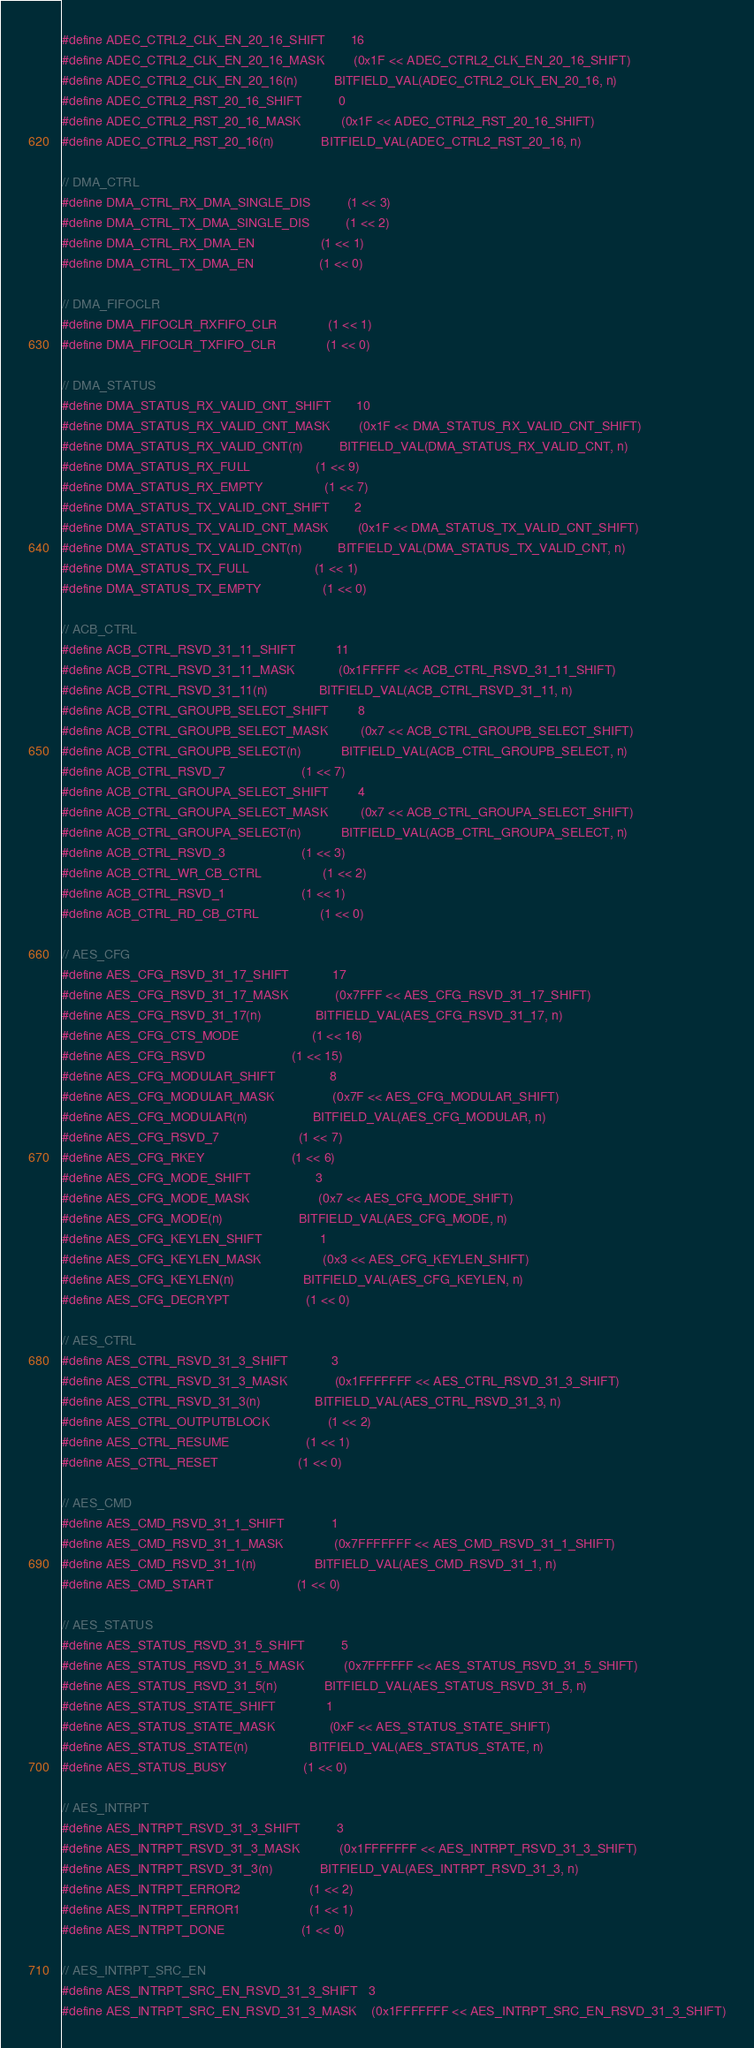Convert code to text. <code><loc_0><loc_0><loc_500><loc_500><_C_>#define ADEC_CTRL2_CLK_EN_20_16_SHIFT       16
#define ADEC_CTRL2_CLK_EN_20_16_MASK        (0x1F << ADEC_CTRL2_CLK_EN_20_16_SHIFT)
#define ADEC_CTRL2_CLK_EN_20_16(n)          BITFIELD_VAL(ADEC_CTRL2_CLK_EN_20_16, n)
#define ADEC_CTRL2_RST_20_16_SHIFT          0
#define ADEC_CTRL2_RST_20_16_MASK           (0x1F << ADEC_CTRL2_RST_20_16_SHIFT)
#define ADEC_CTRL2_RST_20_16(n)             BITFIELD_VAL(ADEC_CTRL2_RST_20_16, n)

// DMA_CTRL
#define DMA_CTRL_RX_DMA_SINGLE_DIS          (1 << 3)
#define DMA_CTRL_TX_DMA_SINGLE_DIS          (1 << 2)
#define DMA_CTRL_RX_DMA_EN                  (1 << 1)
#define DMA_CTRL_TX_DMA_EN                  (1 << 0)

// DMA_FIFOCLR
#define DMA_FIFOCLR_RXFIFO_CLR              (1 << 1)
#define DMA_FIFOCLR_TXFIFO_CLR              (1 << 0)

// DMA_STATUS
#define DMA_STATUS_RX_VALID_CNT_SHIFT       10
#define DMA_STATUS_RX_VALID_CNT_MASK        (0x1F << DMA_STATUS_RX_VALID_CNT_SHIFT)
#define DMA_STATUS_RX_VALID_CNT(n)          BITFIELD_VAL(DMA_STATUS_RX_VALID_CNT, n)
#define DMA_STATUS_RX_FULL                  (1 << 9)
#define DMA_STATUS_RX_EMPTY                 (1 << 7)
#define DMA_STATUS_TX_VALID_CNT_SHIFT       2
#define DMA_STATUS_TX_VALID_CNT_MASK        (0x1F << DMA_STATUS_TX_VALID_CNT_SHIFT)
#define DMA_STATUS_TX_VALID_CNT(n)          BITFIELD_VAL(DMA_STATUS_TX_VALID_CNT, n)
#define DMA_STATUS_TX_FULL                  (1 << 1)
#define DMA_STATUS_TX_EMPTY                 (1 << 0)

// ACB_CTRL
#define ACB_CTRL_RSVD_31_11_SHIFT           11
#define ACB_CTRL_RSVD_31_11_MASK            (0x1FFFFF << ACB_CTRL_RSVD_31_11_SHIFT)
#define ACB_CTRL_RSVD_31_11(n)              BITFIELD_VAL(ACB_CTRL_RSVD_31_11, n)
#define ACB_CTRL_GROUPB_SELECT_SHIFT        8
#define ACB_CTRL_GROUPB_SELECT_MASK         (0x7 << ACB_CTRL_GROUPB_SELECT_SHIFT)
#define ACB_CTRL_GROUPB_SELECT(n)           BITFIELD_VAL(ACB_CTRL_GROUPB_SELECT, n)
#define ACB_CTRL_RSVD_7                     (1 << 7)
#define ACB_CTRL_GROUPA_SELECT_SHIFT        4
#define ACB_CTRL_GROUPA_SELECT_MASK         (0x7 << ACB_CTRL_GROUPA_SELECT_SHIFT)
#define ACB_CTRL_GROUPA_SELECT(n)           BITFIELD_VAL(ACB_CTRL_GROUPA_SELECT, n)
#define ACB_CTRL_RSVD_3                     (1 << 3)
#define ACB_CTRL_WR_CB_CTRL                 (1 << 2)
#define ACB_CTRL_RSVD_1                     (1 << 1)
#define ACB_CTRL_RD_CB_CTRL                 (1 << 0)

// AES_CFG
#define AES_CFG_RSVD_31_17_SHIFT            17
#define AES_CFG_RSVD_31_17_MASK             (0x7FFF << AES_CFG_RSVD_31_17_SHIFT)
#define AES_CFG_RSVD_31_17(n)               BITFIELD_VAL(AES_CFG_RSVD_31_17, n)
#define AES_CFG_CTS_MODE                    (1 << 16)
#define AES_CFG_RSVD                        (1 << 15)
#define AES_CFG_MODULAR_SHIFT               8
#define AES_CFG_MODULAR_MASK                (0x7F << AES_CFG_MODULAR_SHIFT)
#define AES_CFG_MODULAR(n)                  BITFIELD_VAL(AES_CFG_MODULAR, n)
#define AES_CFG_RSVD_7                      (1 << 7)
#define AES_CFG_RKEY                        (1 << 6)
#define AES_CFG_MODE_SHIFT                  3
#define AES_CFG_MODE_MASK                   (0x7 << AES_CFG_MODE_SHIFT)
#define AES_CFG_MODE(n)                     BITFIELD_VAL(AES_CFG_MODE, n)
#define AES_CFG_KEYLEN_SHIFT                1
#define AES_CFG_KEYLEN_MASK                 (0x3 << AES_CFG_KEYLEN_SHIFT)
#define AES_CFG_KEYLEN(n)                   BITFIELD_VAL(AES_CFG_KEYLEN, n)
#define AES_CFG_DECRYPT                     (1 << 0)

// AES_CTRL
#define AES_CTRL_RSVD_31_3_SHIFT            3
#define AES_CTRL_RSVD_31_3_MASK             (0x1FFFFFFF << AES_CTRL_RSVD_31_3_SHIFT)
#define AES_CTRL_RSVD_31_3(n)               BITFIELD_VAL(AES_CTRL_RSVD_31_3, n)
#define AES_CTRL_OUTPUTBLOCK                (1 << 2)
#define AES_CTRL_RESUME                     (1 << 1)
#define AES_CTRL_RESET                      (1 << 0)

// AES_CMD
#define AES_CMD_RSVD_31_1_SHIFT             1
#define AES_CMD_RSVD_31_1_MASK              (0x7FFFFFFF << AES_CMD_RSVD_31_1_SHIFT)
#define AES_CMD_RSVD_31_1(n)                BITFIELD_VAL(AES_CMD_RSVD_31_1, n)
#define AES_CMD_START                       (1 << 0)

// AES_STATUS
#define AES_STATUS_RSVD_31_5_SHIFT          5
#define AES_STATUS_RSVD_31_5_MASK           (0x7FFFFFF << AES_STATUS_RSVD_31_5_SHIFT)
#define AES_STATUS_RSVD_31_5(n)             BITFIELD_VAL(AES_STATUS_RSVD_31_5, n)
#define AES_STATUS_STATE_SHIFT              1
#define AES_STATUS_STATE_MASK               (0xF << AES_STATUS_STATE_SHIFT)
#define AES_STATUS_STATE(n)                 BITFIELD_VAL(AES_STATUS_STATE, n)
#define AES_STATUS_BUSY                     (1 << 0)

// AES_INTRPT
#define AES_INTRPT_RSVD_31_3_SHIFT          3
#define AES_INTRPT_RSVD_31_3_MASK           (0x1FFFFFFF << AES_INTRPT_RSVD_31_3_SHIFT)
#define AES_INTRPT_RSVD_31_3(n)             BITFIELD_VAL(AES_INTRPT_RSVD_31_3, n)
#define AES_INTRPT_ERROR2                   (1 << 2)
#define AES_INTRPT_ERROR1                   (1 << 1)
#define AES_INTRPT_DONE                     (1 << 0)

// AES_INTRPT_SRC_EN
#define AES_INTRPT_SRC_EN_RSVD_31_3_SHIFT   3
#define AES_INTRPT_SRC_EN_RSVD_31_3_MASK    (0x1FFFFFFF << AES_INTRPT_SRC_EN_RSVD_31_3_SHIFT)</code> 